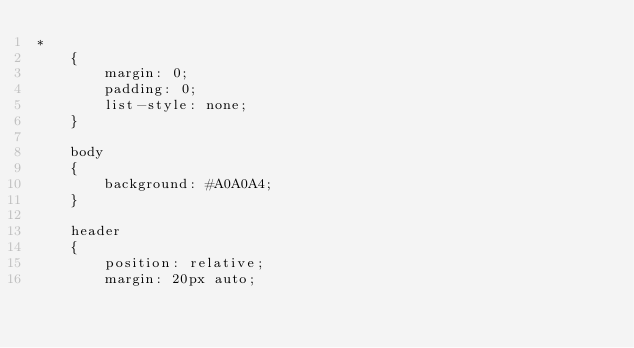Convert code to text. <code><loc_0><loc_0><loc_500><loc_500><_CSS_>*
	{
		margin: 0;
		padding: 0;
		list-style: none;
	}
	
	body
	{
		background: #A0A0A4;
	}
	
	header
	{
		position: relative;
		margin: 20px auto;</code> 